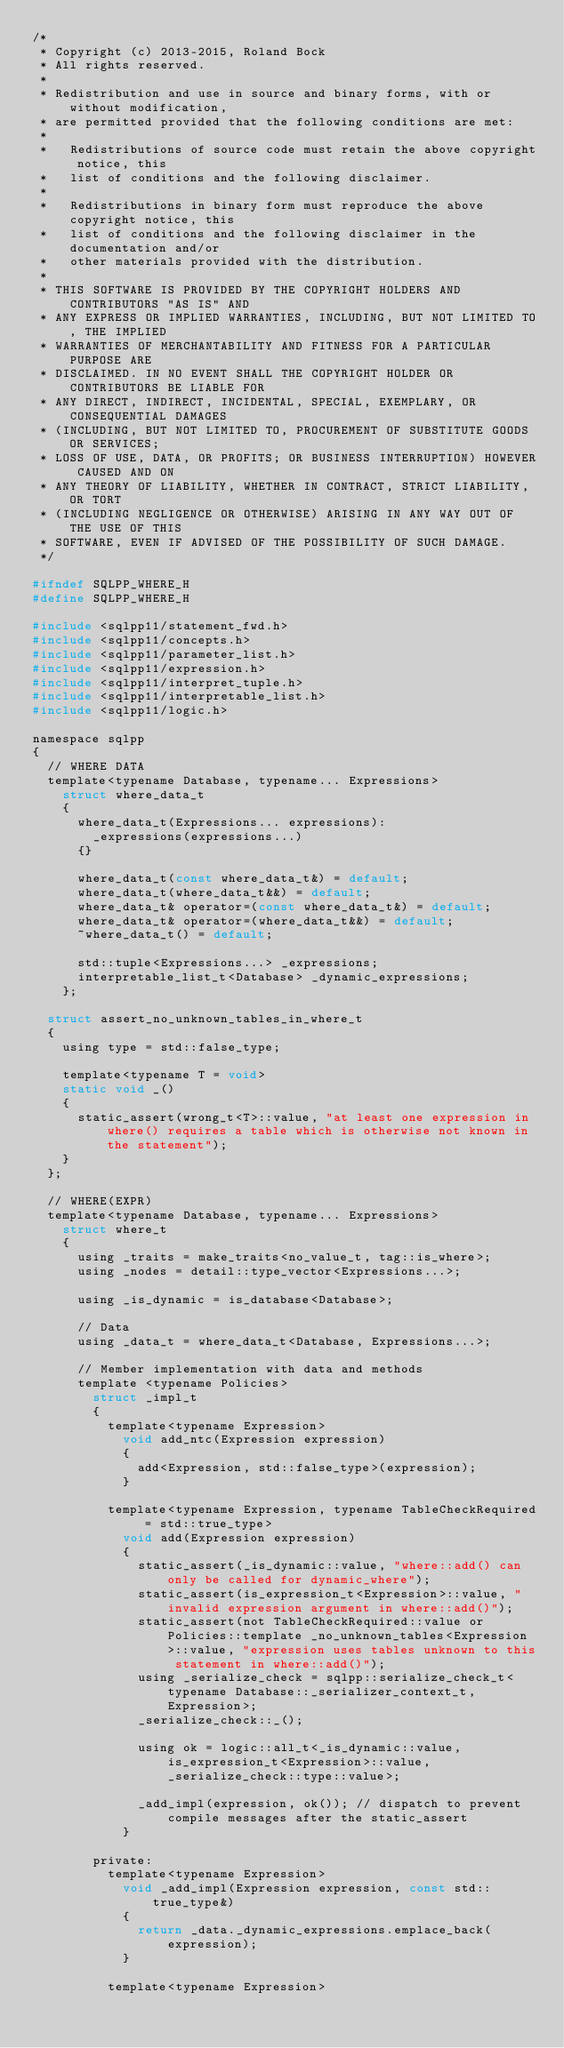Convert code to text. <code><loc_0><loc_0><loc_500><loc_500><_C_>/*
 * Copyright (c) 2013-2015, Roland Bock
 * All rights reserved.
 * 
 * Redistribution and use in source and binary forms, with or without modification,
 * are permitted provided that the following conditions are met:
 * 
 *   Redistributions of source code must retain the above copyright notice, this
 *   list of conditions and the following disclaimer.
 * 
 *   Redistributions in binary form must reproduce the above copyright notice, this
 *   list of conditions and the following disclaimer in the documentation and/or
 *   other materials provided with the distribution.
 * 
 * THIS SOFTWARE IS PROVIDED BY THE COPYRIGHT HOLDERS AND CONTRIBUTORS "AS IS" AND
 * ANY EXPRESS OR IMPLIED WARRANTIES, INCLUDING, BUT NOT LIMITED TO, THE IMPLIED
 * WARRANTIES OF MERCHANTABILITY AND FITNESS FOR A PARTICULAR PURPOSE ARE
 * DISCLAIMED. IN NO EVENT SHALL THE COPYRIGHT HOLDER OR CONTRIBUTORS BE LIABLE FOR
 * ANY DIRECT, INDIRECT, INCIDENTAL, SPECIAL, EXEMPLARY, OR CONSEQUENTIAL DAMAGES
 * (INCLUDING, BUT NOT LIMITED TO, PROCUREMENT OF SUBSTITUTE GOODS OR SERVICES;
 * LOSS OF USE, DATA, OR PROFITS; OR BUSINESS INTERRUPTION) HOWEVER CAUSED AND ON
 * ANY THEORY OF LIABILITY, WHETHER IN CONTRACT, STRICT LIABILITY, OR TORT
 * (INCLUDING NEGLIGENCE OR OTHERWISE) ARISING IN ANY WAY OUT OF THE USE OF THIS
 * SOFTWARE, EVEN IF ADVISED OF THE POSSIBILITY OF SUCH DAMAGE.
 */

#ifndef SQLPP_WHERE_H
#define SQLPP_WHERE_H

#include <sqlpp11/statement_fwd.h>
#include <sqlpp11/concepts.h>
#include <sqlpp11/parameter_list.h>
#include <sqlpp11/expression.h>
#include <sqlpp11/interpret_tuple.h>
#include <sqlpp11/interpretable_list.h>
#include <sqlpp11/logic.h>

namespace sqlpp
{
	// WHERE DATA
	template<typename Database, typename... Expressions>
		struct where_data_t
		{
			where_data_t(Expressions... expressions):
				_expressions(expressions...)
			{}

			where_data_t(const where_data_t&) = default;
			where_data_t(where_data_t&&) = default;
			where_data_t& operator=(const where_data_t&) = default;
			where_data_t& operator=(where_data_t&&) = default;
			~where_data_t() = default;

			std::tuple<Expressions...> _expressions;
			interpretable_list_t<Database> _dynamic_expressions;
		};

	struct assert_no_unknown_tables_in_where_t
	{
		using type = std::false_type;

		template<typename T = void>
		static void _()
		{
			static_assert(wrong_t<T>::value, "at least one expression in where() requires a table which is otherwise not known in the statement");
		}
	};

	// WHERE(EXPR)
	template<typename Database, typename... Expressions>
		struct where_t
		{
			using _traits = make_traits<no_value_t, tag::is_where>;
			using _nodes = detail::type_vector<Expressions...>;

			using _is_dynamic = is_database<Database>;

			// Data
			using _data_t = where_data_t<Database, Expressions...>;

			// Member implementation with data and methods
			template <typename Policies>
				struct _impl_t
				{
					template<typename Expression>
						void add_ntc(Expression expression)
						{
							add<Expression, std::false_type>(expression);
						}

					template<typename Expression, typename TableCheckRequired = std::true_type>
						void add(Expression expression)
						{
							static_assert(_is_dynamic::value, "where::add() can only be called for dynamic_where");
							static_assert(is_expression_t<Expression>::value, "invalid expression argument in where::add()");
							static_assert(not TableCheckRequired::value or Policies::template _no_unknown_tables<Expression>::value, "expression uses tables unknown to this statement in where::add()");
							using _serialize_check = sqlpp::serialize_check_t<typename Database::_serializer_context_t, Expression>;
							_serialize_check::_();

							using ok = logic::all_t<_is_dynamic::value, is_expression_t<Expression>::value, _serialize_check::type::value>;

							_add_impl(expression, ok()); // dispatch to prevent compile messages after the static_assert
						}

				private:
					template<typename Expression>
						void _add_impl(Expression expression, const std::true_type&)
						{
							return _data._dynamic_expressions.emplace_back(expression);
						}

					template<typename Expression></code> 